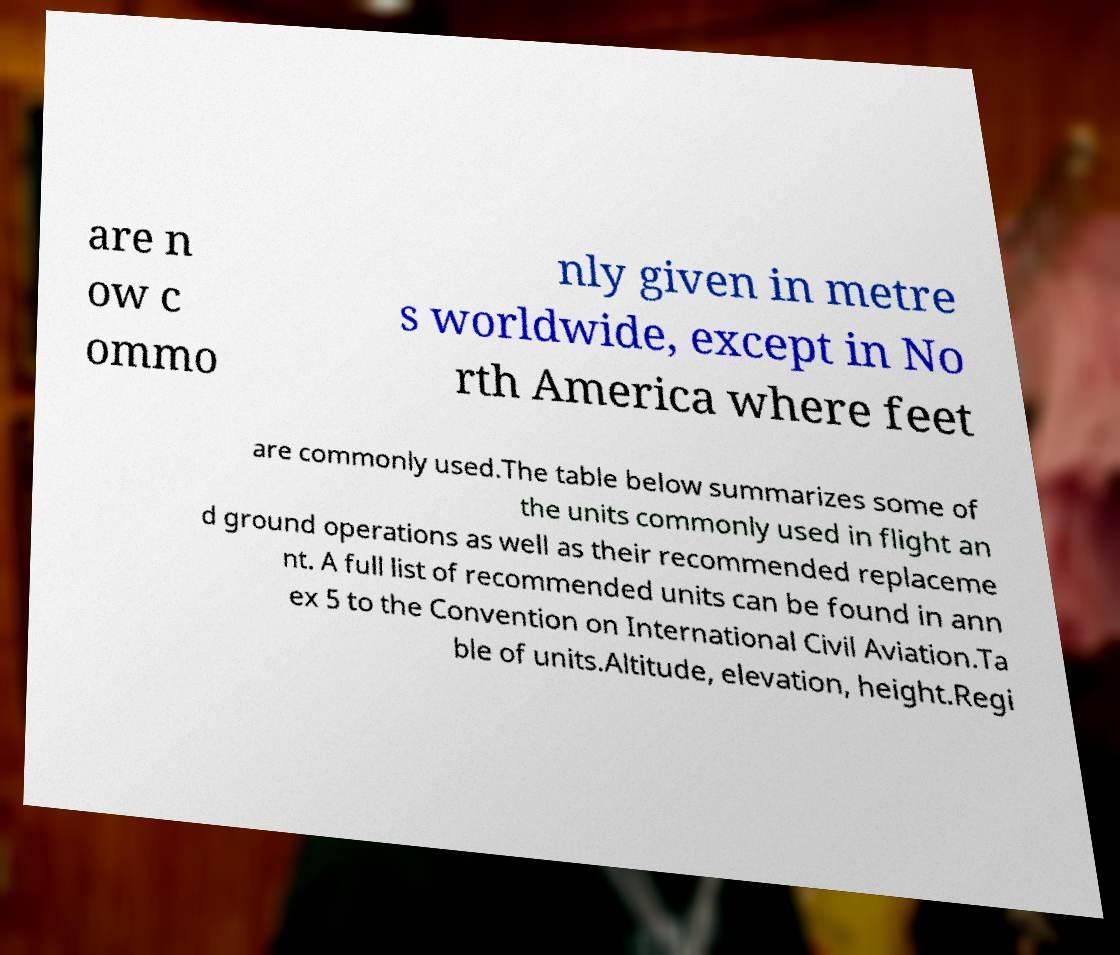I need the written content from this picture converted into text. Can you do that? are n ow c ommo nly given in metre s worldwide, except in No rth America where feet are commonly used.The table below summarizes some of the units commonly used in flight an d ground operations as well as their recommended replaceme nt. A full list of recommended units can be found in ann ex 5 to the Convention on International Civil Aviation.Ta ble of units.Altitude, elevation, height.Regi 